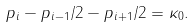<formula> <loc_0><loc_0><loc_500><loc_500>p _ { i } - p _ { i - 1 } / 2 - p _ { i + 1 } / 2 = \kappa _ { 0 } .</formula> 